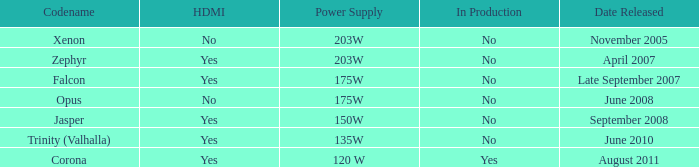Does Trinity (valhalla) have HDMI? Yes. 